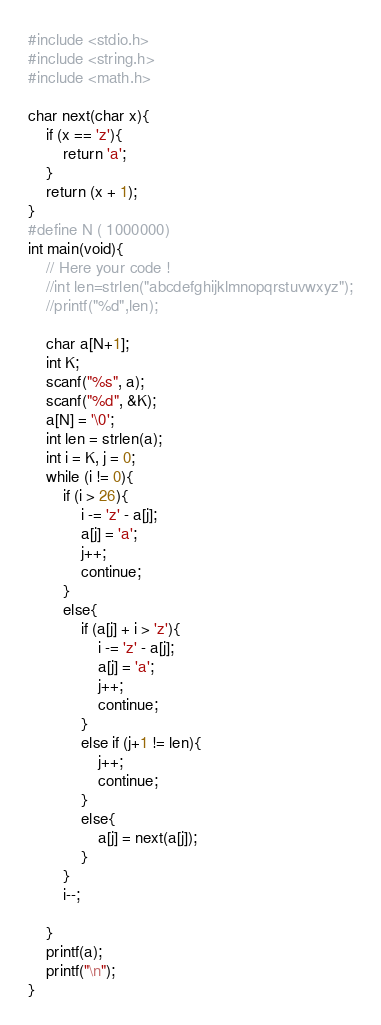Convert code to text. <code><loc_0><loc_0><loc_500><loc_500><_C_>#include <stdio.h>
#include <string.h>
#include <math.h>

char next(char x){
	if (x == 'z'){
		return 'a';
	}
	return (x + 1);
}
#define N ( 1000000)
int main(void){
	// Here your code !
	//int len=strlen("abcdefghijklmnopqrstuvwxyz");
	//printf("%d",len);

	char a[N+1];
	int K;
	scanf("%s", a);
	scanf("%d", &K);
	a[N] = '\0';
	int len = strlen(a);
	int i = K, j = 0;
	while (i != 0){
		if (i > 26){
			i -= 'z' - a[j];
			a[j] = 'a';
			j++;
			continue;
		}
		else{
			if (a[j] + i > 'z'){
				i -= 'z' - a[j];
				a[j] = 'a';
				j++;
				continue;
			}
			else if (j+1 != len){
				j++;
				continue;
			}
			else{
				a[j] = next(a[j]);
			}
		}
		i--;

	}
	printf(a);
	printf("\n");
}

</code> 